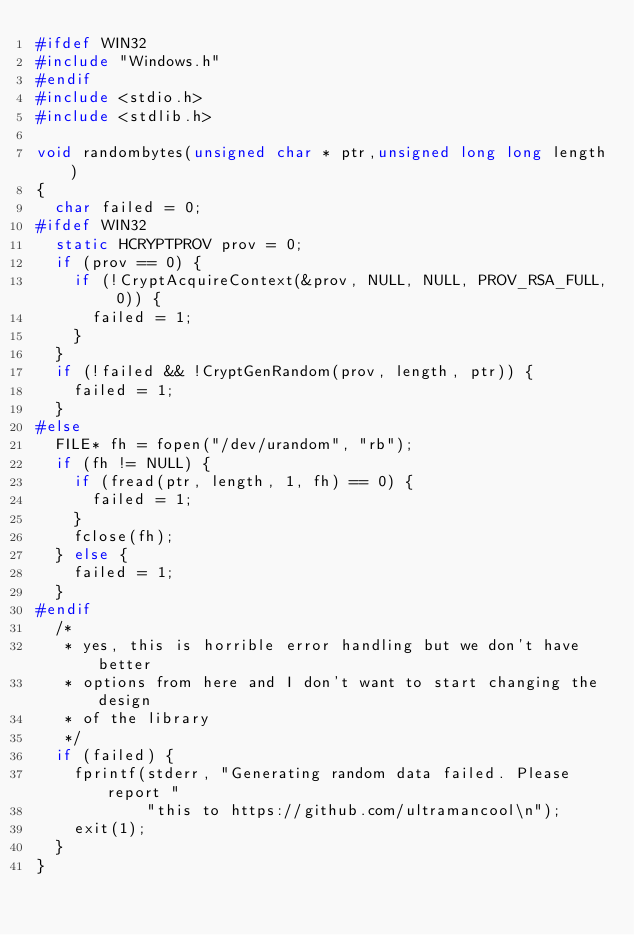<code> <loc_0><loc_0><loc_500><loc_500><_C_>#ifdef WIN32
#include "Windows.h"
#endif
#include <stdio.h>
#include <stdlib.h>

void randombytes(unsigned char * ptr,unsigned long long length)
{
	char failed = 0;
#ifdef WIN32
	static HCRYPTPROV prov = 0;
	if (prov == 0) {
		if (!CryptAcquireContext(&prov, NULL, NULL, PROV_RSA_FULL, 0)) {
			failed = 1;
		}
	}
	if (!failed && !CryptGenRandom(prov, length, ptr)) {
		failed = 1;
	}
#else
	FILE* fh = fopen("/dev/urandom", "rb");
	if (fh != NULL) {
		if (fread(ptr, length, 1, fh) == 0) {
			failed = 1;
		}
		fclose(fh);
	} else {
		failed = 1;
	}
#endif
	/* 
	 * yes, this is horrible error handling but we don't have better 
	 * options from here and I don't want to start changing the design 
	 * of the library 
	 */
	if (failed) {
		fprintf(stderr, "Generating random data failed. Please report "
						"this to https://github.com/ultramancool\n");
		exit(1);
	}
}
</code> 